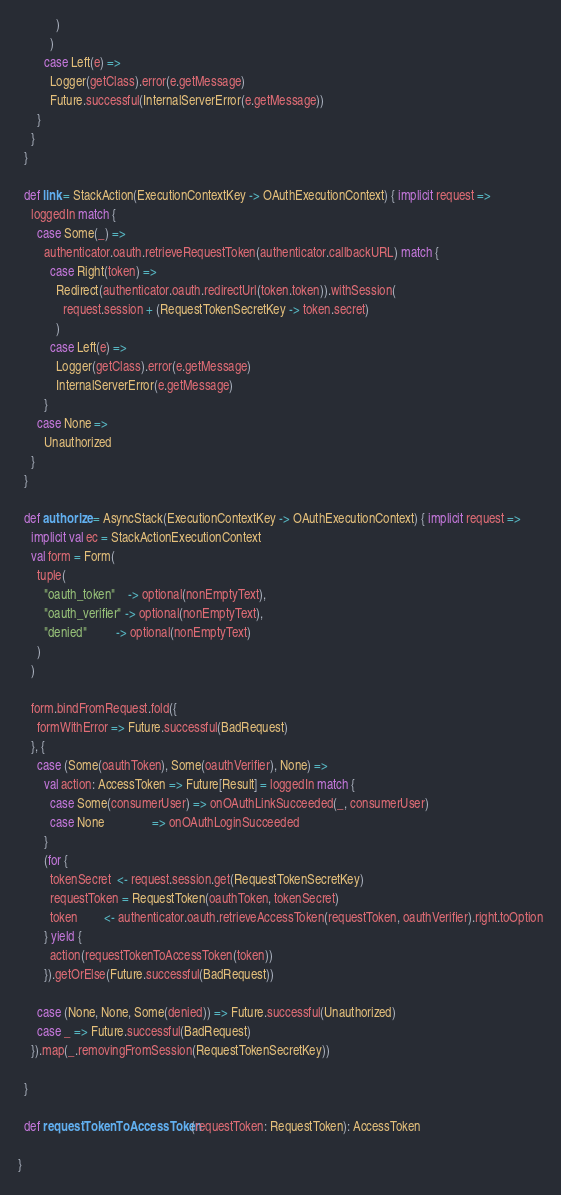Convert code to text. <code><loc_0><loc_0><loc_500><loc_500><_Scala_>            )
          )
        case Left(e) =>
          Logger(getClass).error(e.getMessage)
          Future.successful(InternalServerError(e.getMessage))
      }
    }
  }

  def link = StackAction(ExecutionContextKey -> OAuthExecutionContext) { implicit request =>
    loggedIn match {
      case Some(_) =>
        authenticator.oauth.retrieveRequestToken(authenticator.callbackURL) match {
          case Right(token) =>
            Redirect(authenticator.oauth.redirectUrl(token.token)).withSession(
              request.session + (RequestTokenSecretKey -> token.secret)
            )
          case Left(e) =>
            Logger(getClass).error(e.getMessage)
            InternalServerError(e.getMessage)
        }
      case None =>
        Unauthorized
    }
  }

  def authorize = AsyncStack(ExecutionContextKey -> OAuthExecutionContext) { implicit request =>
    implicit val ec = StackActionExecutionContext
    val form = Form(
      tuple(
        "oauth_token"    -> optional(nonEmptyText),
        "oauth_verifier" -> optional(nonEmptyText),
        "denied"         -> optional(nonEmptyText)
      )
    )

    form.bindFromRequest.fold({
      formWithError => Future.successful(BadRequest)
    }, {
      case (Some(oauthToken), Some(oauthVerifier), None) =>
        val action: AccessToken => Future[Result] = loggedIn match {
          case Some(consumerUser) => onOAuthLinkSucceeded(_, consumerUser)
          case None               => onOAuthLoginSucceeded
        }
        (for {
          tokenSecret  <- request.session.get(RequestTokenSecretKey)
          requestToken = RequestToken(oauthToken, tokenSecret)
          token        <- authenticator.oauth.retrieveAccessToken(requestToken, oauthVerifier).right.toOption
        } yield {
          action(requestTokenToAccessToken(token))
        }).getOrElse(Future.successful(BadRequest))

      case (None, None, Some(denied)) => Future.successful(Unauthorized)
      case _ => Future.successful(BadRequest)
    }).map(_.removingFromSession(RequestTokenSecretKey))

  }

  def requestTokenToAccessToken(requestToken: RequestToken): AccessToken

}

</code> 